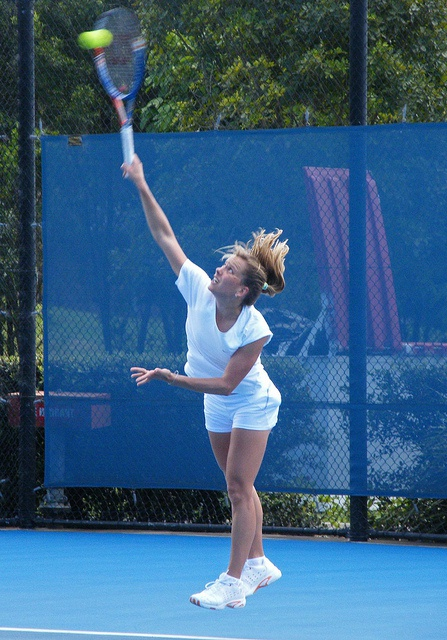Describe the objects in this image and their specific colors. I can see people in darkgreen, gray, lightgray, lightblue, and darkgray tones, tennis racket in darkgreen, gray, and blue tones, and sports ball in darkgreen, lightgreen, khaki, and green tones in this image. 